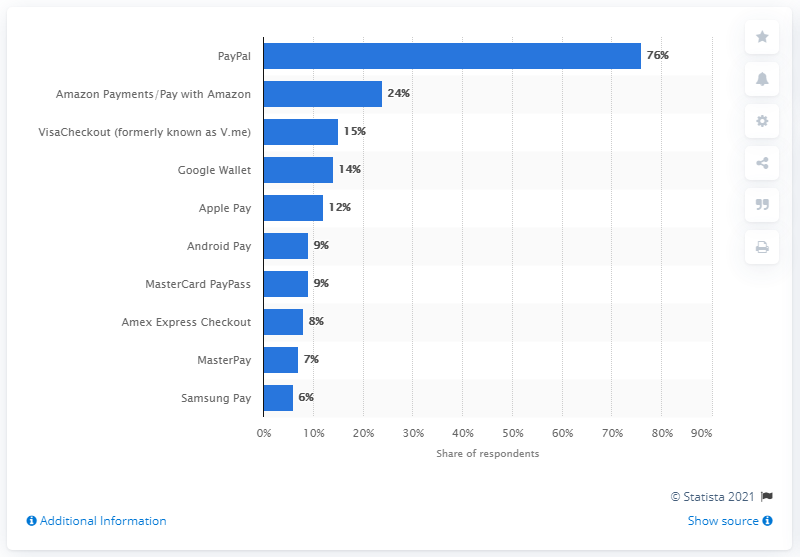Indicate a few pertinent items in this graphic. According to the data, Apple Pay, which was ranked fifth, had a 12 percent usage rate. 